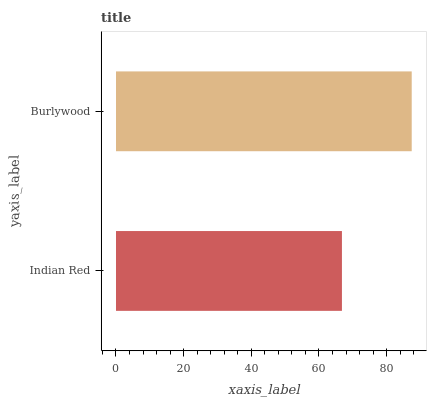Is Indian Red the minimum?
Answer yes or no. Yes. Is Burlywood the maximum?
Answer yes or no. Yes. Is Burlywood the minimum?
Answer yes or no. No. Is Burlywood greater than Indian Red?
Answer yes or no. Yes. Is Indian Red less than Burlywood?
Answer yes or no. Yes. Is Indian Red greater than Burlywood?
Answer yes or no. No. Is Burlywood less than Indian Red?
Answer yes or no. No. Is Burlywood the high median?
Answer yes or no. Yes. Is Indian Red the low median?
Answer yes or no. Yes. Is Indian Red the high median?
Answer yes or no. No. Is Burlywood the low median?
Answer yes or no. No. 